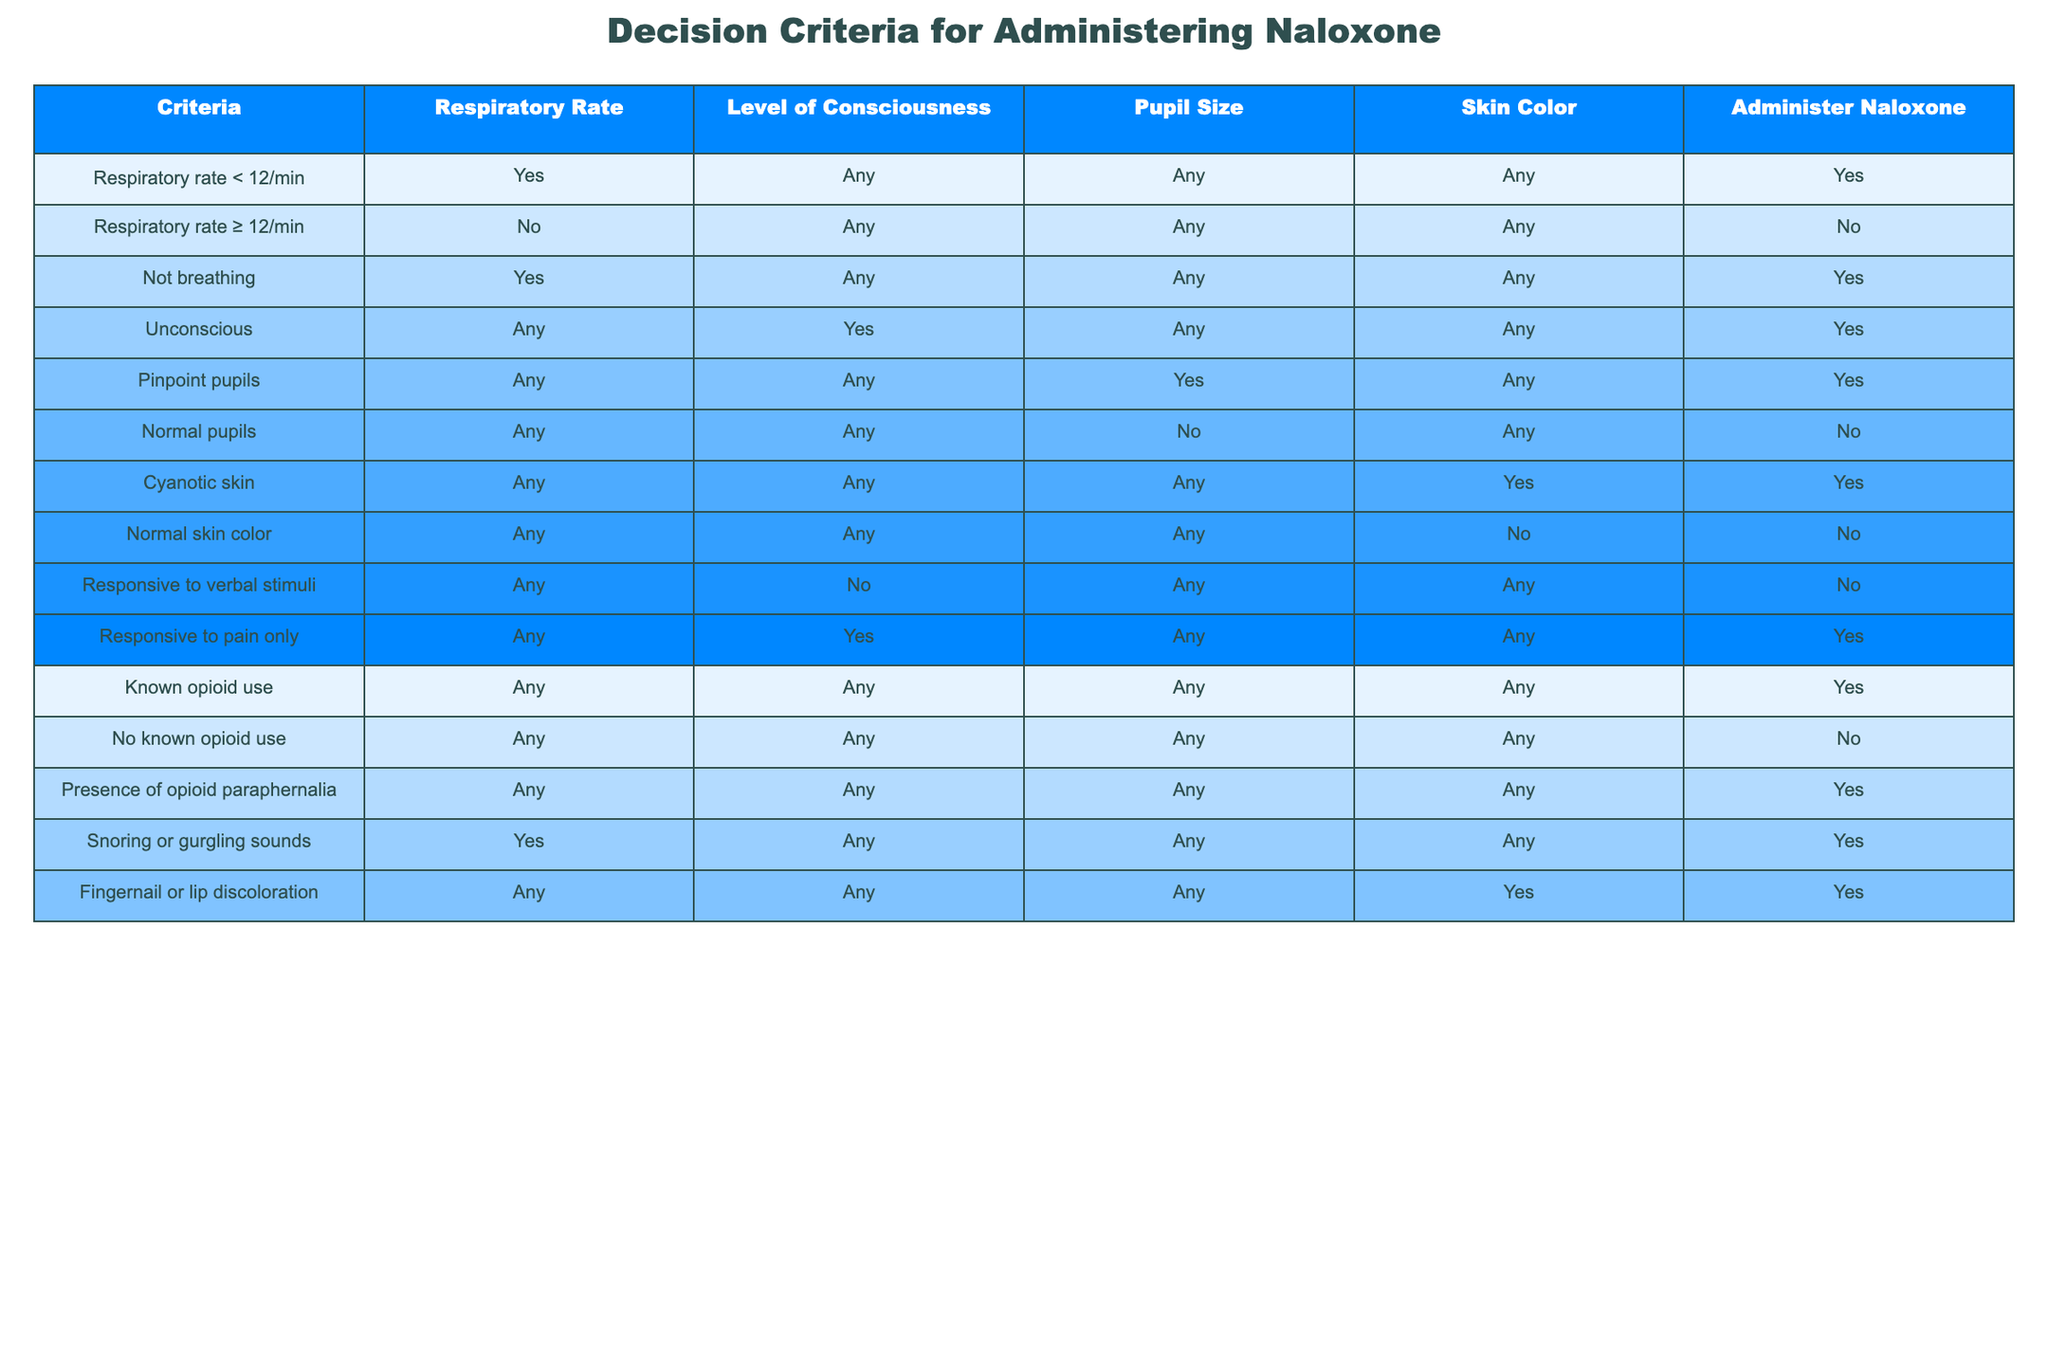What is the criteria for administering Naloxone if the respiratory rate is less than 12/min? According to the table, if the respiratory rate is less than 12/min, Naloxone should be administered regardless of the level of consciousness, pupil size, or skin color, as indicated in the corresponding row under "Administer Naloxone."
Answer: Yes Is Naloxone administered if the patient is not breathing? The table clearly indicates that if a patient is not breathing, Naloxone should be administered without consideration of other factors. This is stated in the row with specifics under the "Respiratory Rate" column.
Answer: Yes How many criteria indicate that Naloxone should be administered if the patient has pinpoint pupils? Upon reviewing the table, the presence of pinpoint pupils is a specific criterion that calls for the administration of Naloxone. This is outlined in one row without combining other factors. Therefore, the answer is one clear condition.
Answer: 1 What are the total criteria that require Naloxone administration based on respiratory rate less than 12/min, unconsciousness, and the presence of opioid paraphernalia? By evaluating the table, we see that three criteria align with administering Naloxone: if the respiratory rate is less than 12/min, the patient is unconscious, or there is a presence of opioid paraphernalia. Each condition separately indicates to administer Naloxone, resulting in a total of three.
Answer: 3 If a patient is responsive to pain only, should Naloxone be administered? The table specifies that if a patient is responsive to pain only, Naloxone should indeed be administered. This is explicitly noted in the row that describes the criteria for this specific level of responsiveness.
Answer: Yes Does having normal pupils negate the need for Naloxone administration? Yes, according to the table, if a patient has normal pupils, it is specified that Naloxone is not to be administered. This is directly referenced in the row related to "Normal pupils" under the "Administer Naloxone" column.
Answer: Yes In the case of known opioid use, what is the decision about administering Naloxone? The table clearly states that if there is known opioid use, Naloxone should be administered without considering other factors, as mentioned in the corresponding row. This highlights the importance of known opioid usage in decision-making for Naloxone administration.
Answer: Yes Among the criteria listed in the table, how many lead to administering Naloxone due to skin color changes? There are two criteria related to skin color changes in the table: cyanotic skin does indicate Naloxone should be administered, while normal skin color does not. Thus, only the presence of cyanotic skin leads to a decision for administering Naloxone based solely on skin color.
Answer: 1 